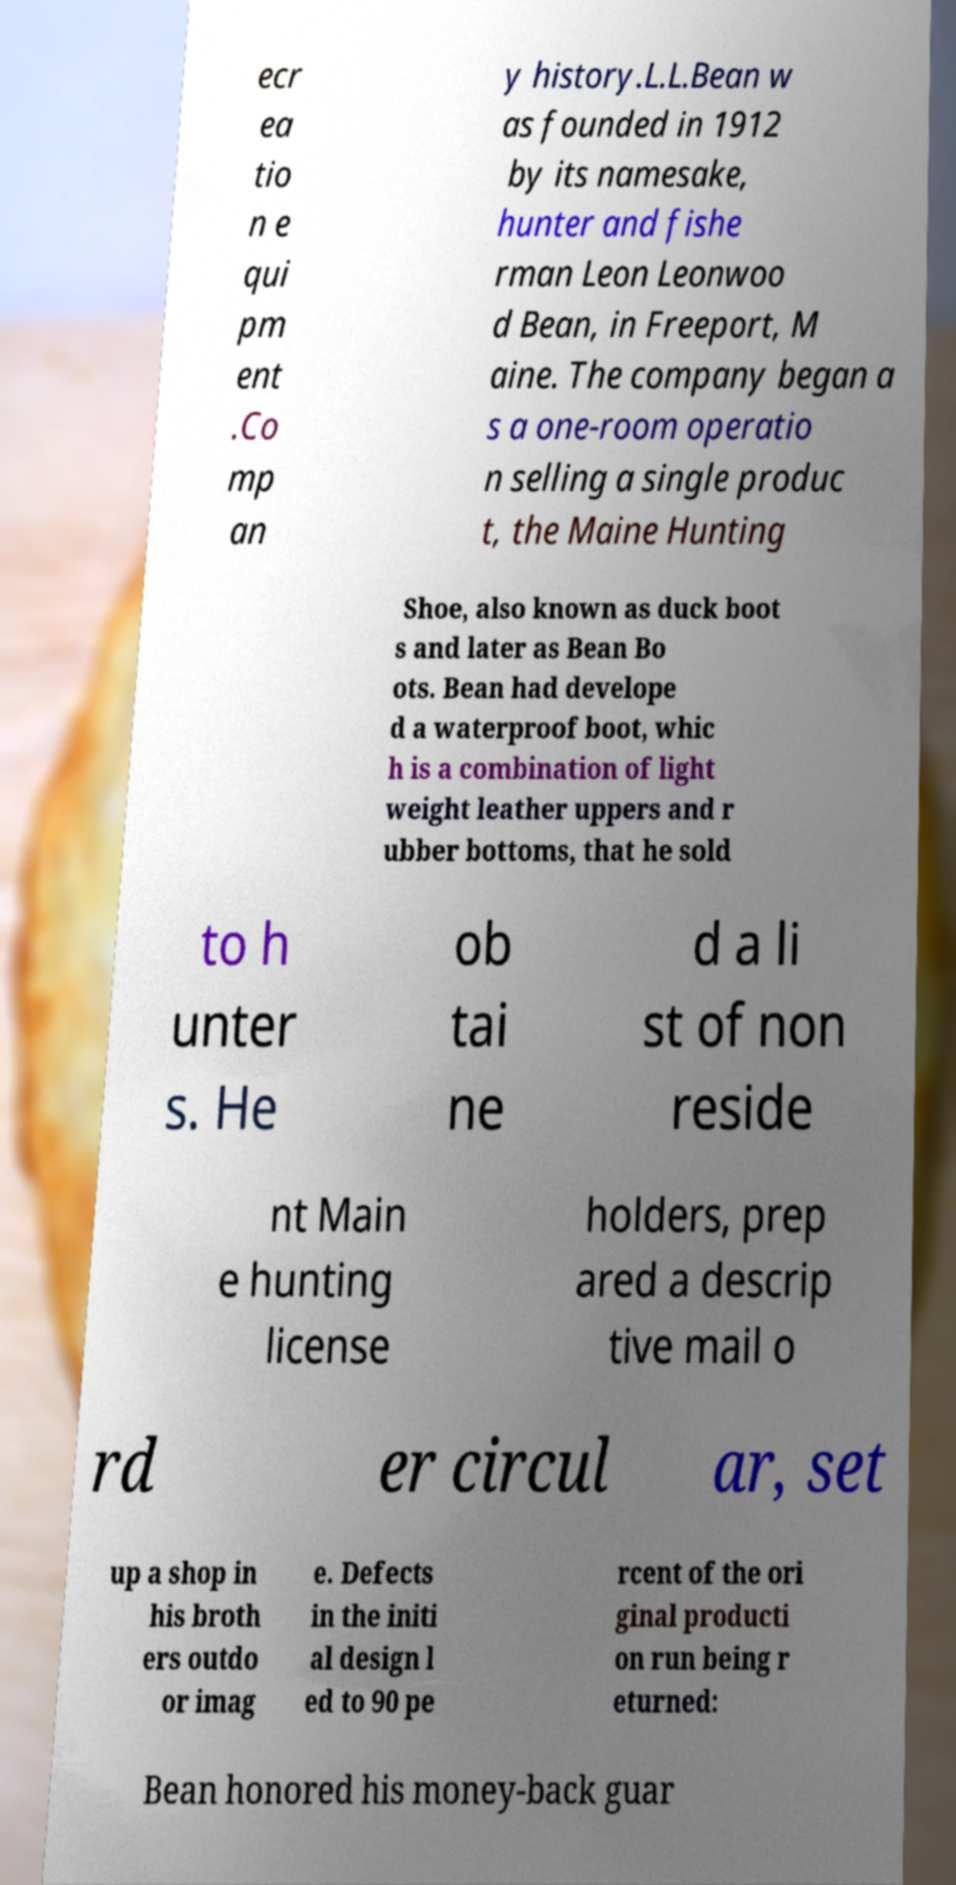Could you assist in decoding the text presented in this image and type it out clearly? ecr ea tio n e qui pm ent .Co mp an y history.L.L.Bean w as founded in 1912 by its namesake, hunter and fishe rman Leon Leonwoo d Bean, in Freeport, M aine. The company began a s a one-room operatio n selling a single produc t, the Maine Hunting Shoe, also known as duck boot s and later as Bean Bo ots. Bean had develope d a waterproof boot, whic h is a combination of light weight leather uppers and r ubber bottoms, that he sold to h unter s. He ob tai ne d a li st of non reside nt Main e hunting license holders, prep ared a descrip tive mail o rd er circul ar, set up a shop in his broth ers outdo or imag e. Defects in the initi al design l ed to 90 pe rcent of the ori ginal producti on run being r eturned: Bean honored his money-back guar 